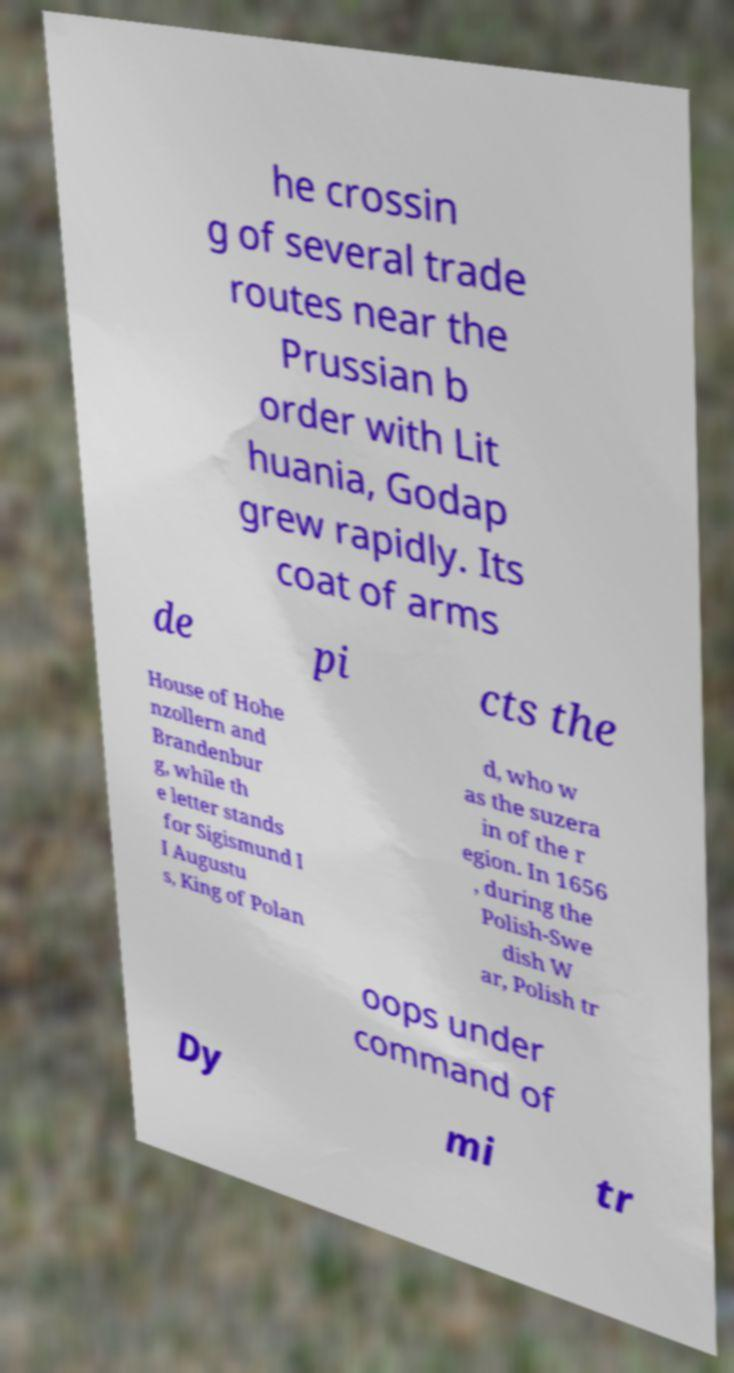Could you extract and type out the text from this image? he crossin g of several trade routes near the Prussian b order with Lit huania, Godap grew rapidly. Its coat of arms de pi cts the House of Hohe nzollern and Brandenbur g, while th e letter stands for Sigismund I I Augustu s, King of Polan d, who w as the suzera in of the r egion. In 1656 , during the Polish-Swe dish W ar, Polish tr oops under command of Dy mi tr 